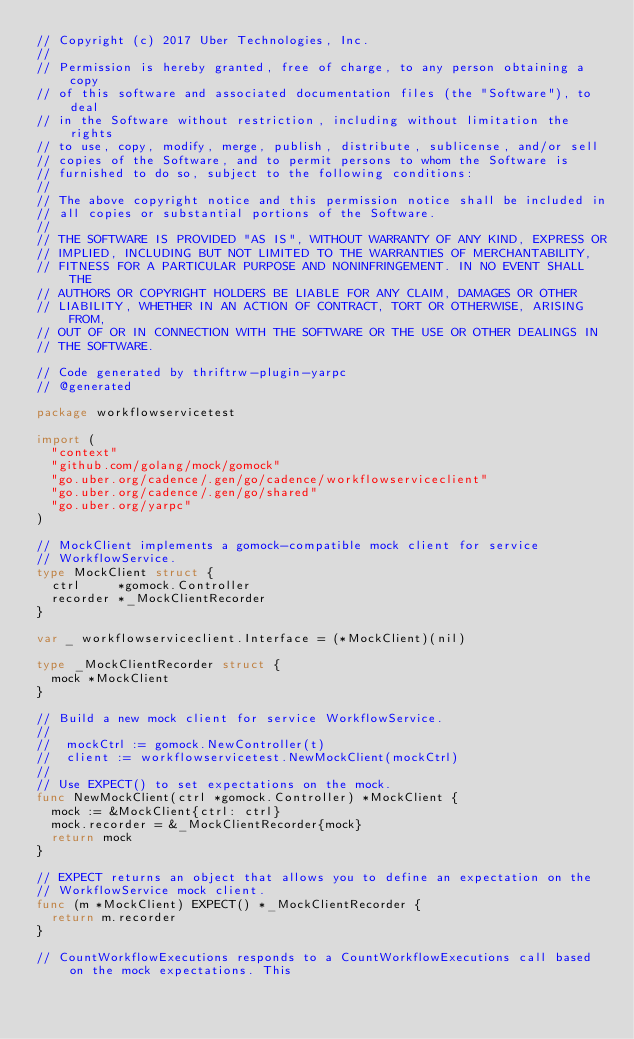Convert code to text. <code><loc_0><loc_0><loc_500><loc_500><_Go_>// Copyright (c) 2017 Uber Technologies, Inc.
//
// Permission is hereby granted, free of charge, to any person obtaining a copy
// of this software and associated documentation files (the "Software"), to deal
// in the Software without restriction, including without limitation the rights
// to use, copy, modify, merge, publish, distribute, sublicense, and/or sell
// copies of the Software, and to permit persons to whom the Software is
// furnished to do so, subject to the following conditions:
//
// The above copyright notice and this permission notice shall be included in
// all copies or substantial portions of the Software.
//
// THE SOFTWARE IS PROVIDED "AS IS", WITHOUT WARRANTY OF ANY KIND, EXPRESS OR
// IMPLIED, INCLUDING BUT NOT LIMITED TO THE WARRANTIES OF MERCHANTABILITY,
// FITNESS FOR A PARTICULAR PURPOSE AND NONINFRINGEMENT. IN NO EVENT SHALL THE
// AUTHORS OR COPYRIGHT HOLDERS BE LIABLE FOR ANY CLAIM, DAMAGES OR OTHER
// LIABILITY, WHETHER IN AN ACTION OF CONTRACT, TORT OR OTHERWISE, ARISING FROM,
// OUT OF OR IN CONNECTION WITH THE SOFTWARE OR THE USE OR OTHER DEALINGS IN
// THE SOFTWARE.

// Code generated by thriftrw-plugin-yarpc
// @generated

package workflowservicetest

import (
	"context"
	"github.com/golang/mock/gomock"
	"go.uber.org/cadence/.gen/go/cadence/workflowserviceclient"
	"go.uber.org/cadence/.gen/go/shared"
	"go.uber.org/yarpc"
)

// MockClient implements a gomock-compatible mock client for service
// WorkflowService.
type MockClient struct {
	ctrl     *gomock.Controller
	recorder *_MockClientRecorder
}

var _ workflowserviceclient.Interface = (*MockClient)(nil)

type _MockClientRecorder struct {
	mock *MockClient
}

// Build a new mock client for service WorkflowService.
//
// 	mockCtrl := gomock.NewController(t)
// 	client := workflowservicetest.NewMockClient(mockCtrl)
//
// Use EXPECT() to set expectations on the mock.
func NewMockClient(ctrl *gomock.Controller) *MockClient {
	mock := &MockClient{ctrl: ctrl}
	mock.recorder = &_MockClientRecorder{mock}
	return mock
}

// EXPECT returns an object that allows you to define an expectation on the
// WorkflowService mock client.
func (m *MockClient) EXPECT() *_MockClientRecorder {
	return m.recorder
}

// CountWorkflowExecutions responds to a CountWorkflowExecutions call based on the mock expectations. This</code> 